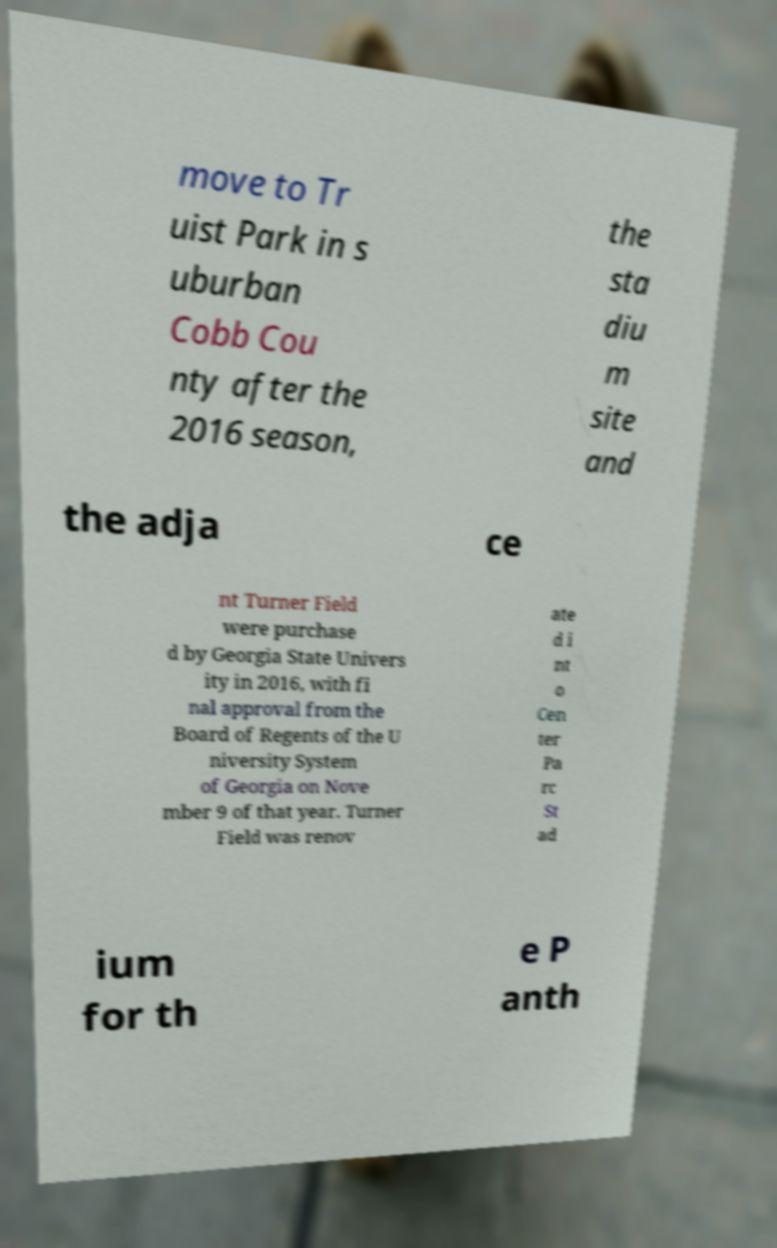For documentation purposes, I need the text within this image transcribed. Could you provide that? move to Tr uist Park in s uburban Cobb Cou nty after the 2016 season, the sta diu m site and the adja ce nt Turner Field were purchase d by Georgia State Univers ity in 2016, with fi nal approval from the Board of Regents of the U niversity System of Georgia on Nove mber 9 of that year. Turner Field was renov ate d i nt o Cen ter Pa rc St ad ium for th e P anth 